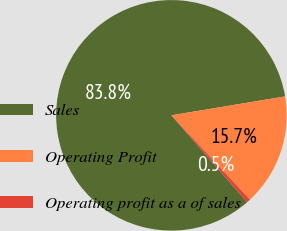Convert chart. <chart><loc_0><loc_0><loc_500><loc_500><pie_chart><fcel>Sales<fcel>Operating Profit<fcel>Operating profit as a of sales<nl><fcel>83.79%<fcel>15.68%<fcel>0.53%<nl></chart> 